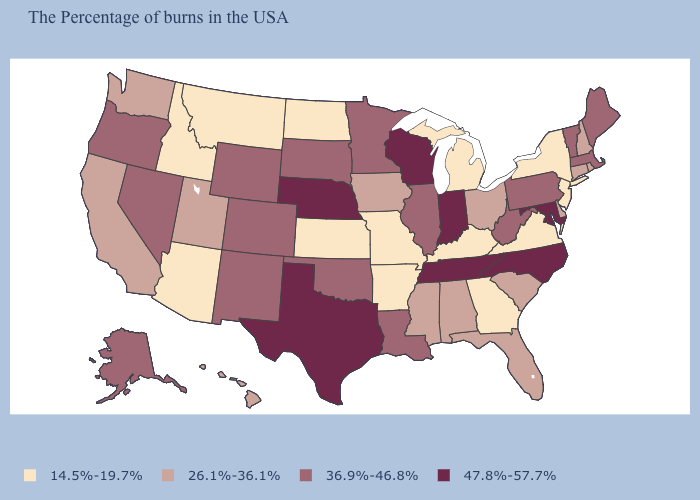Which states have the highest value in the USA?
Concise answer only. Maryland, North Carolina, Indiana, Tennessee, Wisconsin, Nebraska, Texas. Does North Dakota have the highest value in the USA?
Write a very short answer. No. What is the value of Arizona?
Quick response, please. 14.5%-19.7%. What is the value of Massachusetts?
Quick response, please. 36.9%-46.8%. What is the value of Arkansas?
Keep it brief. 14.5%-19.7%. Does Arkansas have a lower value than Montana?
Short answer required. No. Does New Jersey have the lowest value in the USA?
Give a very brief answer. Yes. Does Utah have a higher value than Nebraska?
Answer briefly. No. Does the first symbol in the legend represent the smallest category?
Keep it brief. Yes. Name the states that have a value in the range 36.9%-46.8%?
Write a very short answer. Maine, Massachusetts, Vermont, Pennsylvania, West Virginia, Illinois, Louisiana, Minnesota, Oklahoma, South Dakota, Wyoming, Colorado, New Mexico, Nevada, Oregon, Alaska. Does the map have missing data?
Keep it brief. No. Does Montana have the lowest value in the West?
Give a very brief answer. Yes. What is the value of Florida?
Quick response, please. 26.1%-36.1%. Does New Jersey have a higher value than Louisiana?
Give a very brief answer. No. 